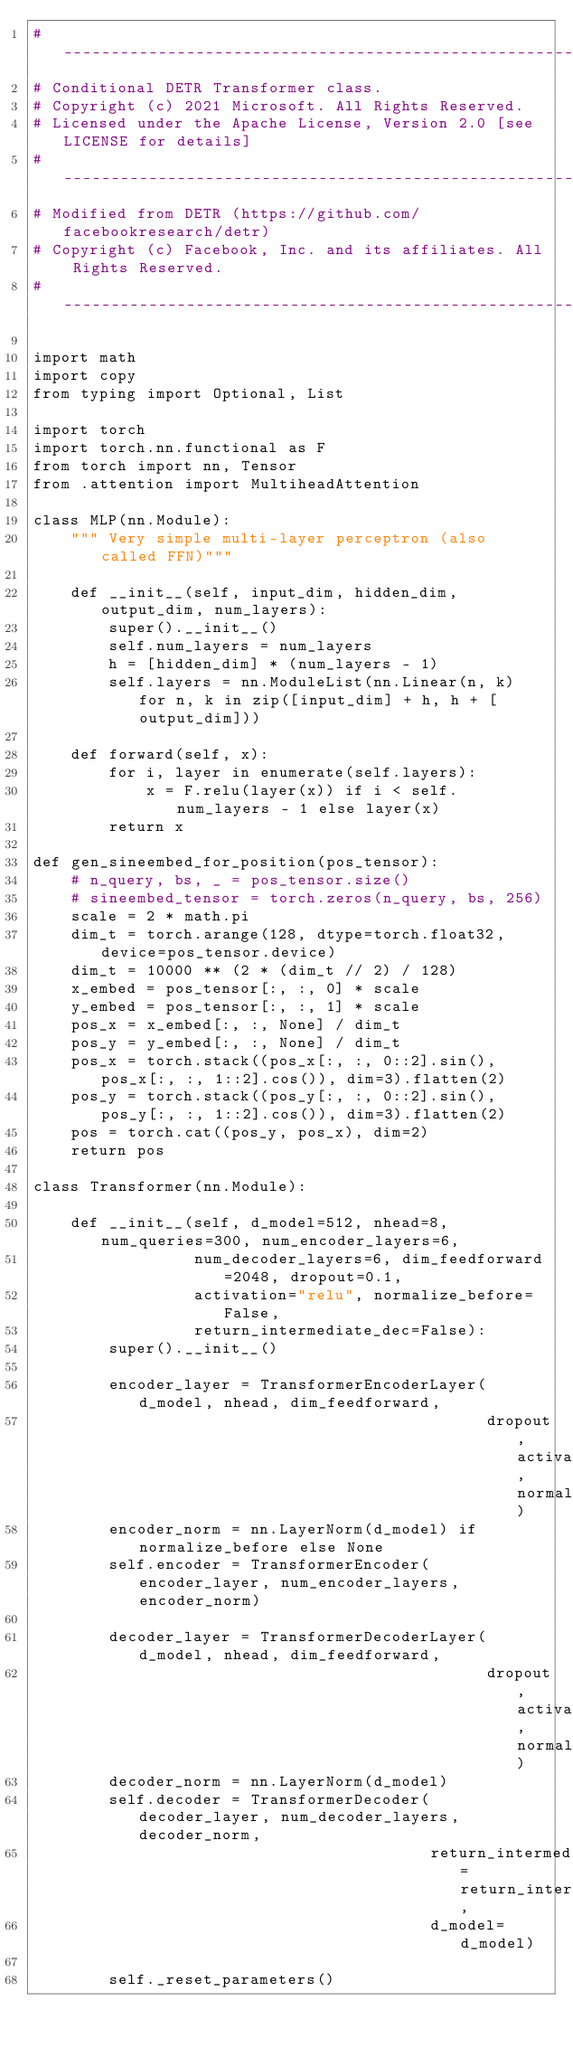Convert code to text. <code><loc_0><loc_0><loc_500><loc_500><_Python_># ------------------------------------------------------------------------
# Conditional DETR Transformer class.
# Copyright (c) 2021 Microsoft. All Rights Reserved.
# Licensed under the Apache License, Version 2.0 [see LICENSE for details]
# ------------------------------------------------------------------------
# Modified from DETR (https://github.com/facebookresearch/detr)
# Copyright (c) Facebook, Inc. and its affiliates. All Rights Reserved.
# ------------------------------------------------------------------------

import math
import copy
from typing import Optional, List

import torch
import torch.nn.functional as F
from torch import nn, Tensor
from .attention import MultiheadAttention

class MLP(nn.Module):
    """ Very simple multi-layer perceptron (also called FFN)"""

    def __init__(self, input_dim, hidden_dim, output_dim, num_layers):
        super().__init__()
        self.num_layers = num_layers
        h = [hidden_dim] * (num_layers - 1)
        self.layers = nn.ModuleList(nn.Linear(n, k) for n, k in zip([input_dim] + h, h + [output_dim]))

    def forward(self, x):
        for i, layer in enumerate(self.layers):
            x = F.relu(layer(x)) if i < self.num_layers - 1 else layer(x)
        return x

def gen_sineembed_for_position(pos_tensor):
    # n_query, bs, _ = pos_tensor.size()
    # sineembed_tensor = torch.zeros(n_query, bs, 256)
    scale = 2 * math.pi
    dim_t = torch.arange(128, dtype=torch.float32, device=pos_tensor.device)
    dim_t = 10000 ** (2 * (dim_t // 2) / 128)
    x_embed = pos_tensor[:, :, 0] * scale
    y_embed = pos_tensor[:, :, 1] * scale
    pos_x = x_embed[:, :, None] / dim_t
    pos_y = y_embed[:, :, None] / dim_t
    pos_x = torch.stack((pos_x[:, :, 0::2].sin(), pos_x[:, :, 1::2].cos()), dim=3).flatten(2)
    pos_y = torch.stack((pos_y[:, :, 0::2].sin(), pos_y[:, :, 1::2].cos()), dim=3).flatten(2)
    pos = torch.cat((pos_y, pos_x), dim=2)
    return pos

class Transformer(nn.Module):

    def __init__(self, d_model=512, nhead=8, num_queries=300, num_encoder_layers=6,
                 num_decoder_layers=6, dim_feedforward=2048, dropout=0.1,
                 activation="relu", normalize_before=False,
                 return_intermediate_dec=False):
        super().__init__()

        encoder_layer = TransformerEncoderLayer(d_model, nhead, dim_feedforward,
                                                dropout, activation, normalize_before)
        encoder_norm = nn.LayerNorm(d_model) if normalize_before else None
        self.encoder = TransformerEncoder(encoder_layer, num_encoder_layers, encoder_norm)

        decoder_layer = TransformerDecoderLayer(d_model, nhead, dim_feedforward,
                                                dropout, activation, normalize_before)
        decoder_norm = nn.LayerNorm(d_model)
        self.decoder = TransformerDecoder(decoder_layer, num_decoder_layers, decoder_norm,
                                          return_intermediate=return_intermediate_dec,
                                          d_model=d_model)

        self._reset_parameters()
</code> 